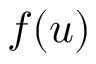Convert formula to latex. <formula><loc_0><loc_0><loc_500><loc_500>f ( u )</formula> 